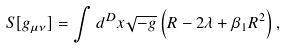Convert formula to latex. <formula><loc_0><loc_0><loc_500><loc_500>S [ g _ { \mu \nu } ] = \int { d } ^ { D } x \sqrt { - g } \left ( R - 2 \lambda + \beta _ { 1 } { R } ^ { 2 } \right ) ,</formula> 